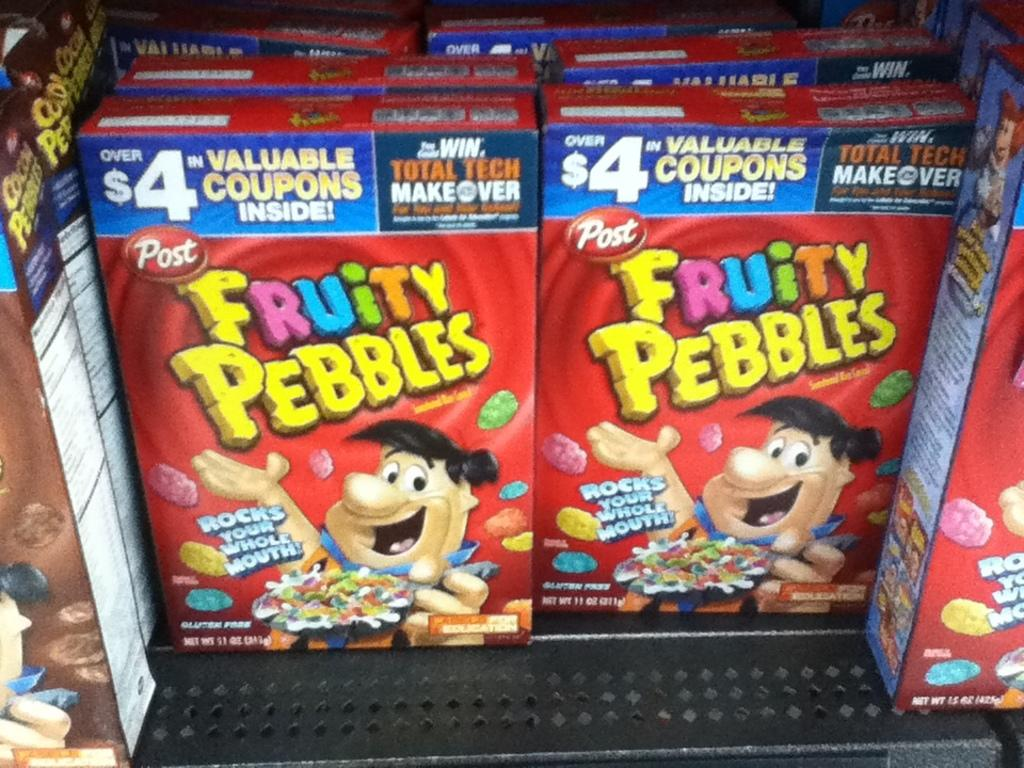What objects are present in the image? There are boxes in the image. Where are the boxes located? The boxes are placed on a metal surface. What type of images are on the boxes? The boxes have cartoon images on them. What else can be found on the boxes? There is text on the boxes. How many vans can be seen driving through the land in the image? There are no vans or land visible in the image; it only features boxes on a metal surface. 